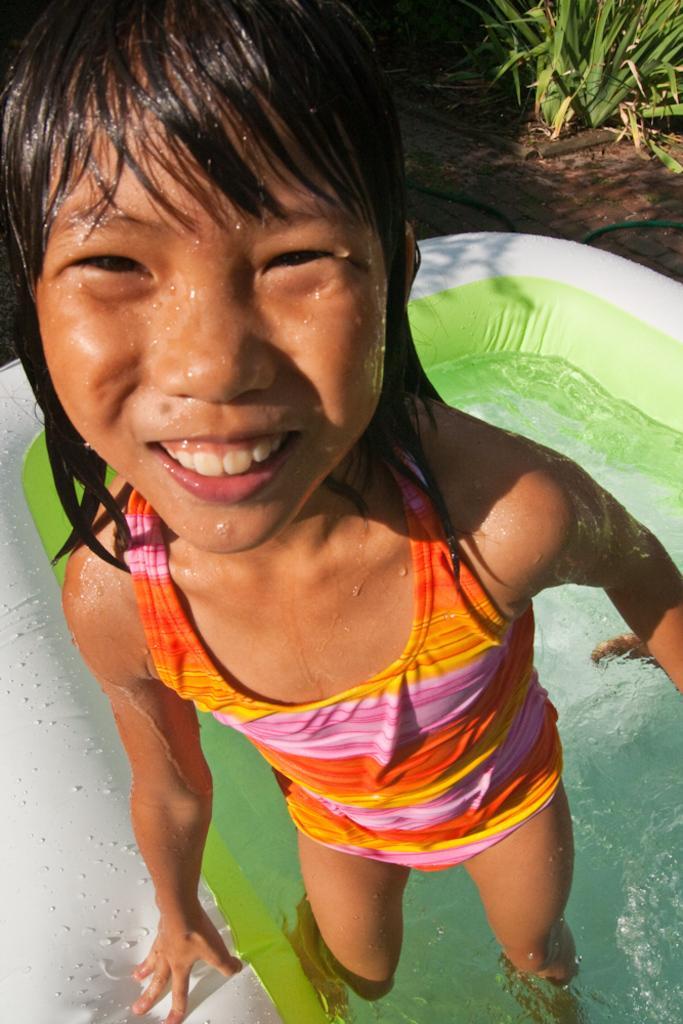Can you describe this image briefly? In this image I can see a girl is standing and I can see she is wearing swimming costume. In the background I can see water tube and in it I can see water. On the top right side of this image I can see a plant. 